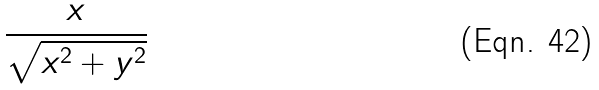Convert formula to latex. <formula><loc_0><loc_0><loc_500><loc_500>\frac { x } { \sqrt { x ^ { 2 } + y ^ { 2 } } }</formula> 